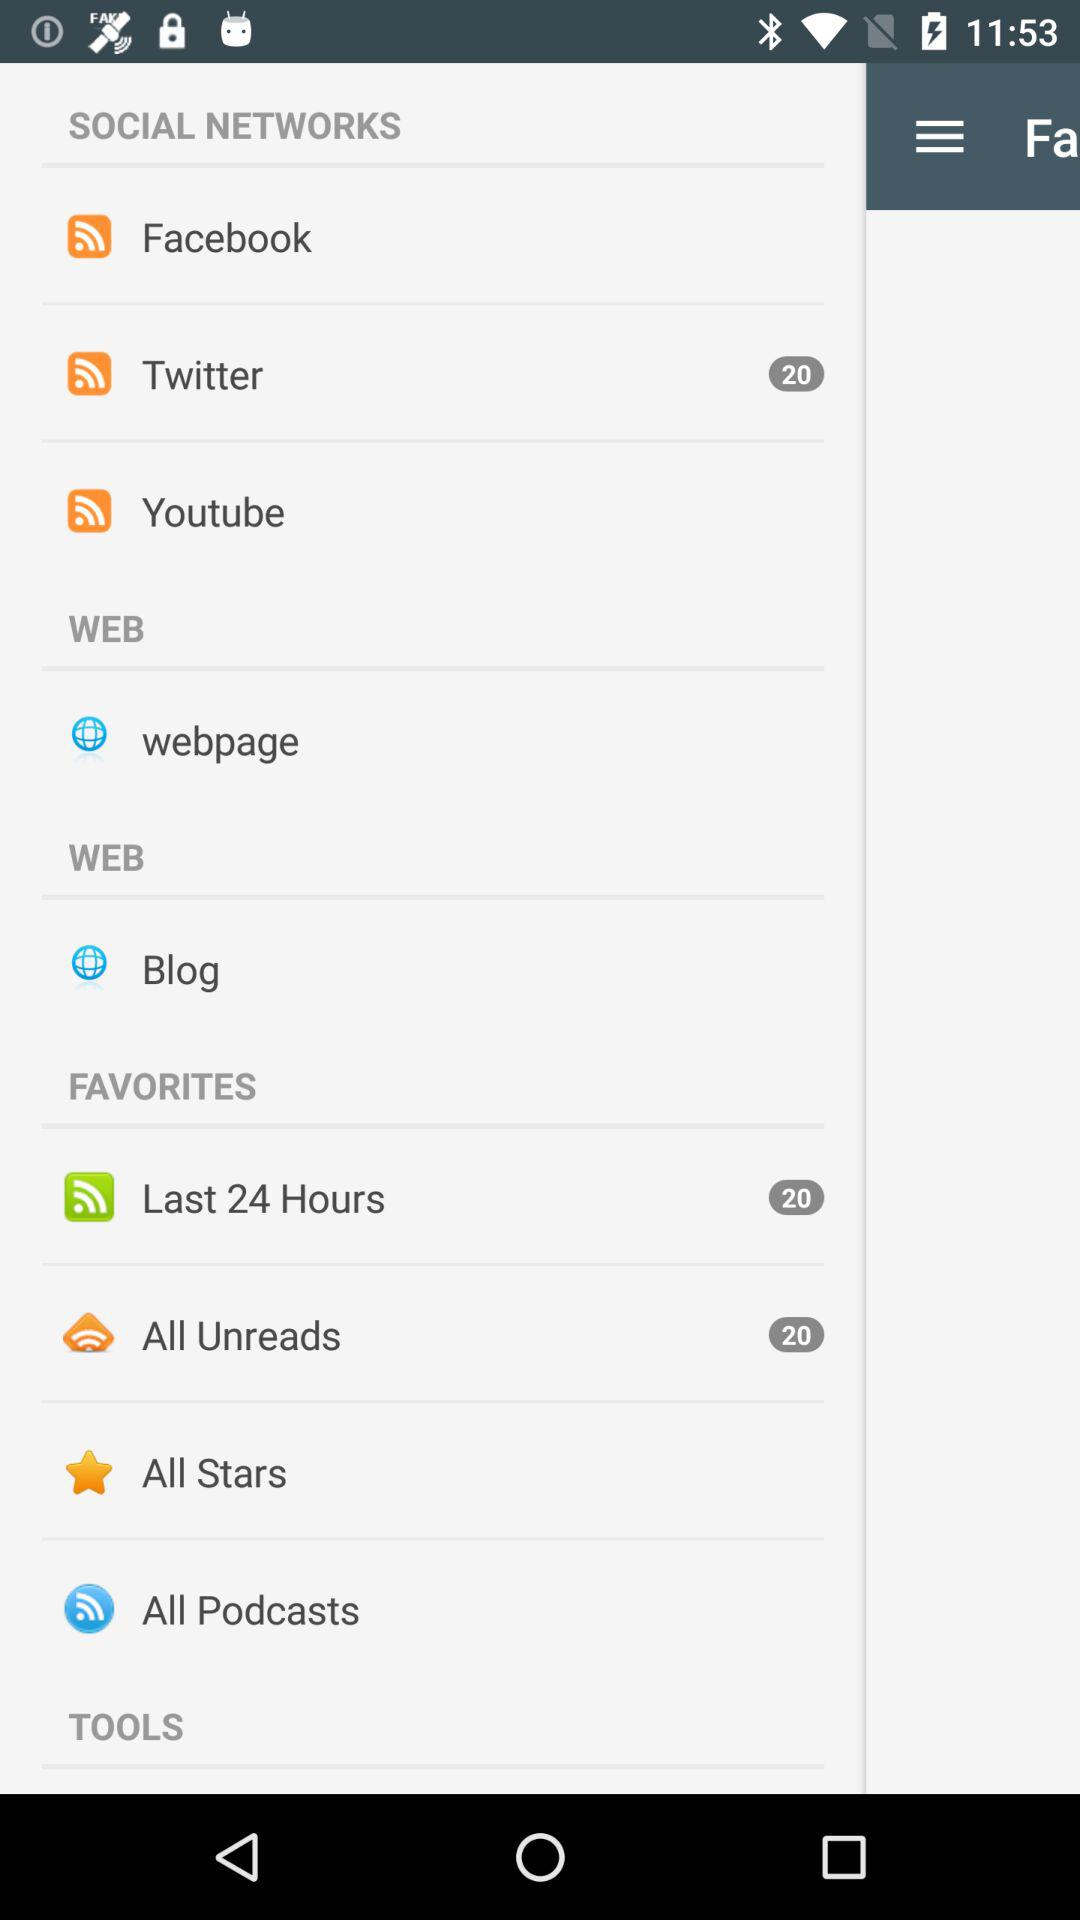How many notifications are pending on Twitter? There are 20 notifications pending. 